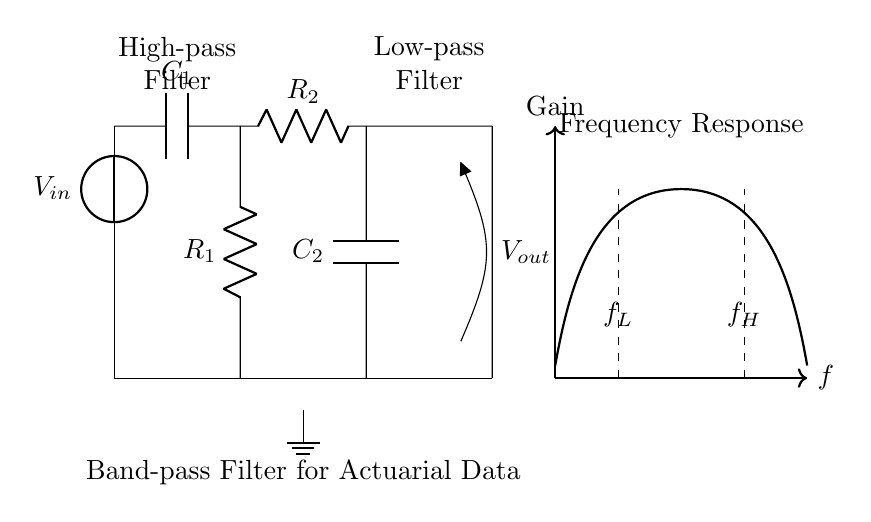What does the output voltage represent? The output voltage, denoted as Vout, represents the voltage across the output terminals of the band-pass filter, which is where the isolated frequency range is measured.
Answer: Vout What are the components of the high-pass section? The high-pass section consists of a capacitor, labeled C1, and a resistor, labeled R1. They are connected in such a way that the capacitor blocks low frequencies while allowing high frequencies to pass.
Answer: C1 and R1 What is the function of C2? C2 is a capacitor in the low-pass section, which blocks high frequencies and allows low frequencies to pass, contributing to the overall band-pass filter functionality.
Answer: Block high frequencies What are the cut-off frequencies of this filter? The cut-off frequencies are labeled as f_L for the lower cut-off frequency and f_H for the higher cut-off frequency, defining the range of frequencies that the filter allows to pass.
Answer: f_L and f_H How does the band-pass filter affect the signals? The band-pass filter selectively allows signals within the range between f_L and f_H to pass through, while attenuating signals outside this range; thus, it isolates specific frequency ranges in the dataset.
Answer: Isolates frequency ranges What is the role of R2 in the circuit? R2 is a resistor in the low-pass section of the filter that works with C2 to define the cut-off frequency for higher frequency signals, ensuring that only frequencies below a certain point are allowed through.
Answer: Defines cut-off frequency 